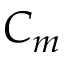Convert formula to latex. <formula><loc_0><loc_0><loc_500><loc_500>C _ { m }</formula> 